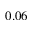<formula> <loc_0><loc_0><loc_500><loc_500>0 . 0 6</formula> 